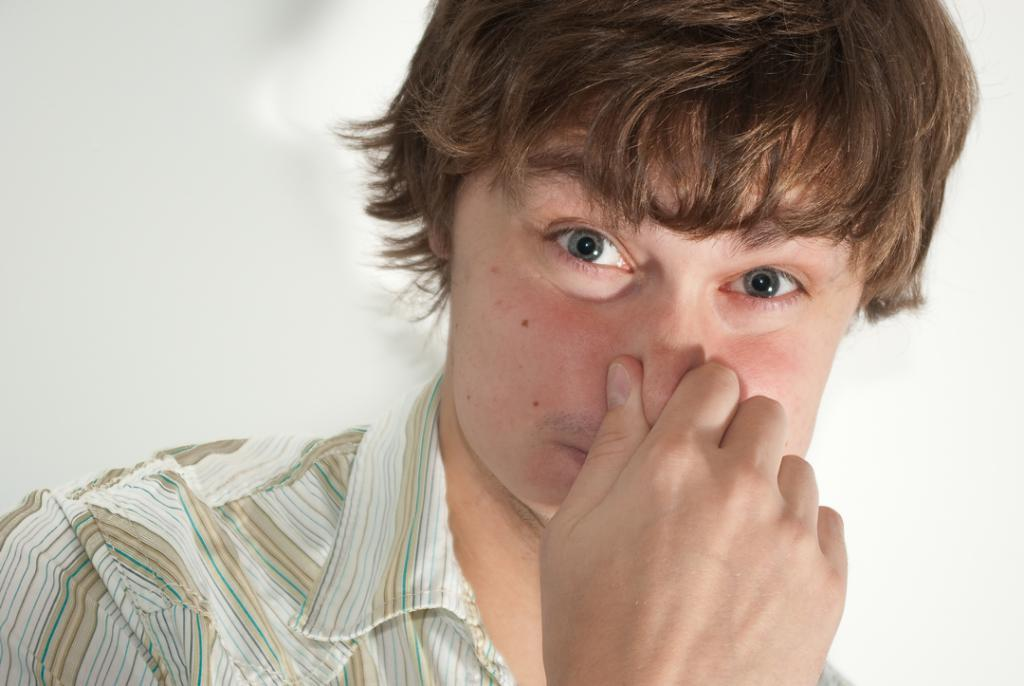What is the main subject of the image? There is a person in the image. What is the person doing in the image? The person is holding their nose. What can be seen in the background of the image? There is a well in the background of the image. What color is the sweater worn by the frog in the image? There is no frog or sweater present in the image. How many robins can be seen flying around the well in the image? There are no robins present in the image. 